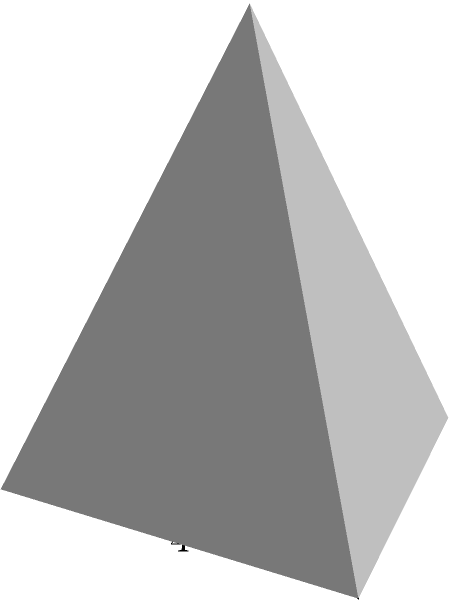As the director of the museum, you're overseeing the construction of a new pyramid-shaped exhibit structure. The base is a square with sides measuring 4 meters, and the height of the pyramid is 5 meters. To ensure proper conservation of the artifacts inside, you need to calculate the total surface area of the structure, including the base. What is the total surface area of the pyramid-shaped exhibit in square meters? Let's approach this step-by-step:

1) First, we need to calculate the area of the base:
   Base area = $4 \text{ m} \times 4 \text{ m} = 16 \text{ m}^2$

2) Next, we need to find the slant height of the pyramid. We can do this using the Pythagorean theorem:
   Let $s$ be the slant height and $d$ be half the diagonal of the base.
   
   $d^2 = 2^2 + 2^2 = 8$, so $d = 2\sqrt{2}$
   
   Now, $s^2 = 5^2 + (2\sqrt{2})^2 = 25 + 8 = 33$
   
   Therefore, $s = \sqrt{33}$ meters

3) The area of each triangular face is:
   Face area = $\frac{1}{2} \times 4 \text{ m} \times \sqrt{33} \text{ m} = 2\sqrt{33} \text{ m}^2$

4) There are four identical triangular faces, so:
   Total area of sides = $4 \times 2\sqrt{33} \text{ m}^2 = 8\sqrt{33} \text{ m}^2$

5) The total surface area is the sum of the base area and the area of all four sides:
   Total surface area = $16 \text{ m}^2 + 8\sqrt{33} \text{ m}^2 = (16 + 8\sqrt{33}) \text{ m}^2$

6) To simplify, we can leave it as $(16 + 8\sqrt{33}) \text{ m}^2$ or calculate the approximate value:
   $16 + 8\sqrt{33} \approx 61.97 \text{ m}^2$
Answer: $(16 + 8\sqrt{33}) \text{ m}^2$ or approximately $61.97 \text{ m}^2$ 